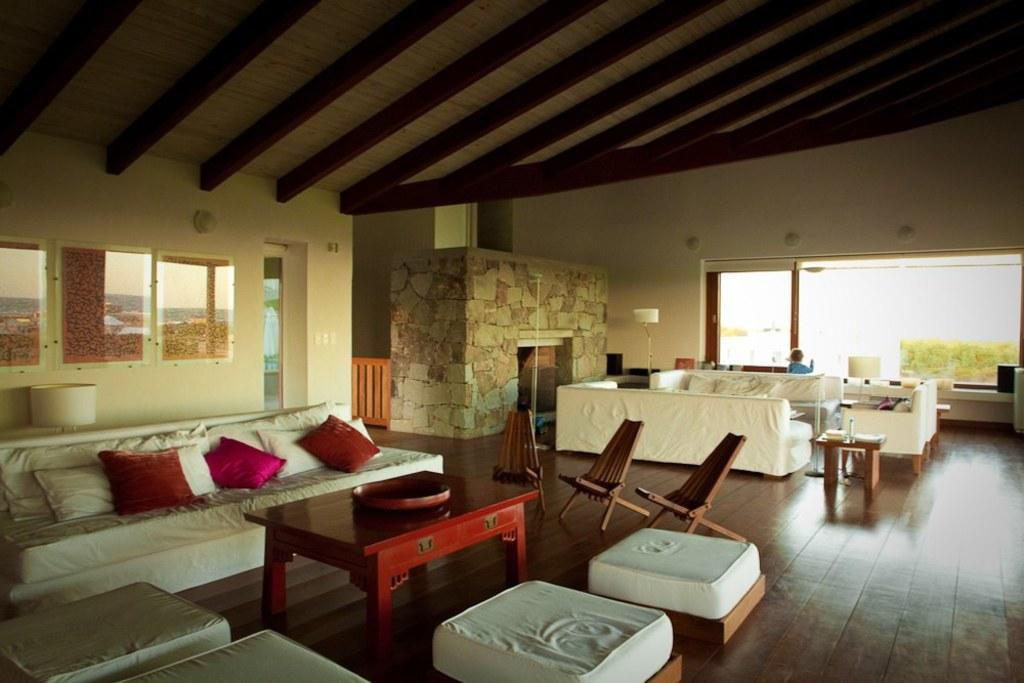What type of furniture is present in the image? There is a piece of furniture in the image. Can you describe the furniture on the left side of the image? There is a sofa on the left side of the image. What is located in the center of the image? There is a wooden table in the center of the image. What other piece of furniture can be seen on the right side of the image? There is a wooden chair on the right side of the image. Is there any source of natural light in the image? Yes, there is a window in the image. How many cats are sitting on the wooden table in the image? There are no cats present in the image. 